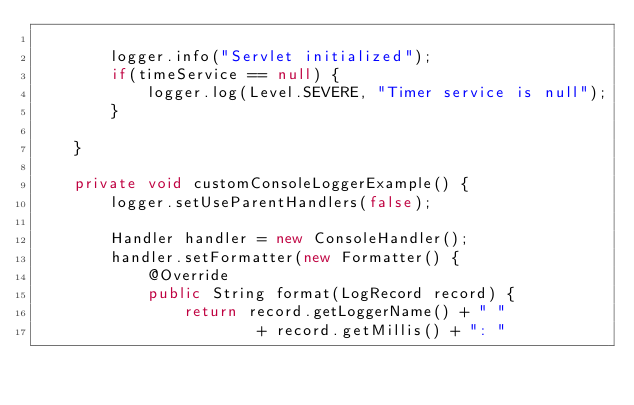<code> <loc_0><loc_0><loc_500><loc_500><_Java_>
        logger.info("Servlet initialized");
        if(timeService == null) {
            logger.log(Level.SEVERE, "Timer service is null");
        }

    }

    private void customConsoleLoggerExample() {
        logger.setUseParentHandlers(false);

        Handler handler = new ConsoleHandler();
        handler.setFormatter(new Formatter() {
            @Override
            public String format(LogRecord record) {
                return record.getLoggerName() + " "
                        + record.getMillis() + ": "</code> 